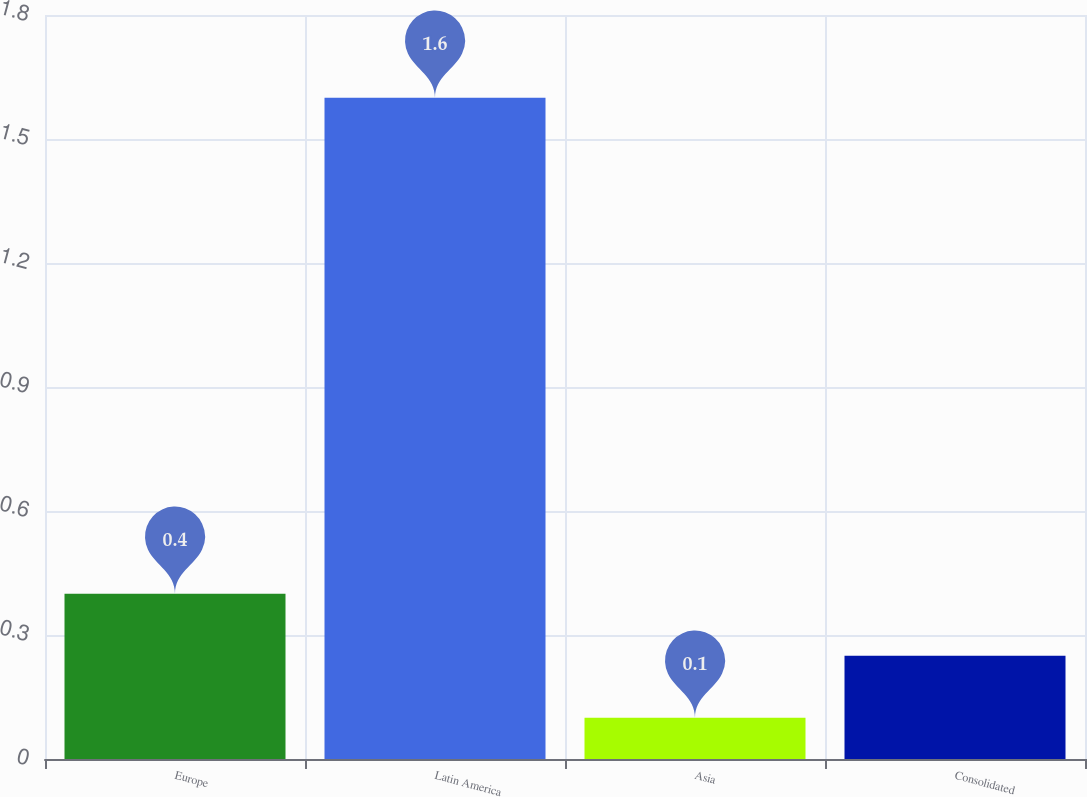<chart> <loc_0><loc_0><loc_500><loc_500><bar_chart><fcel>Europe<fcel>Latin America<fcel>Asia<fcel>Consolidated<nl><fcel>0.4<fcel>1.6<fcel>0.1<fcel>0.25<nl></chart> 